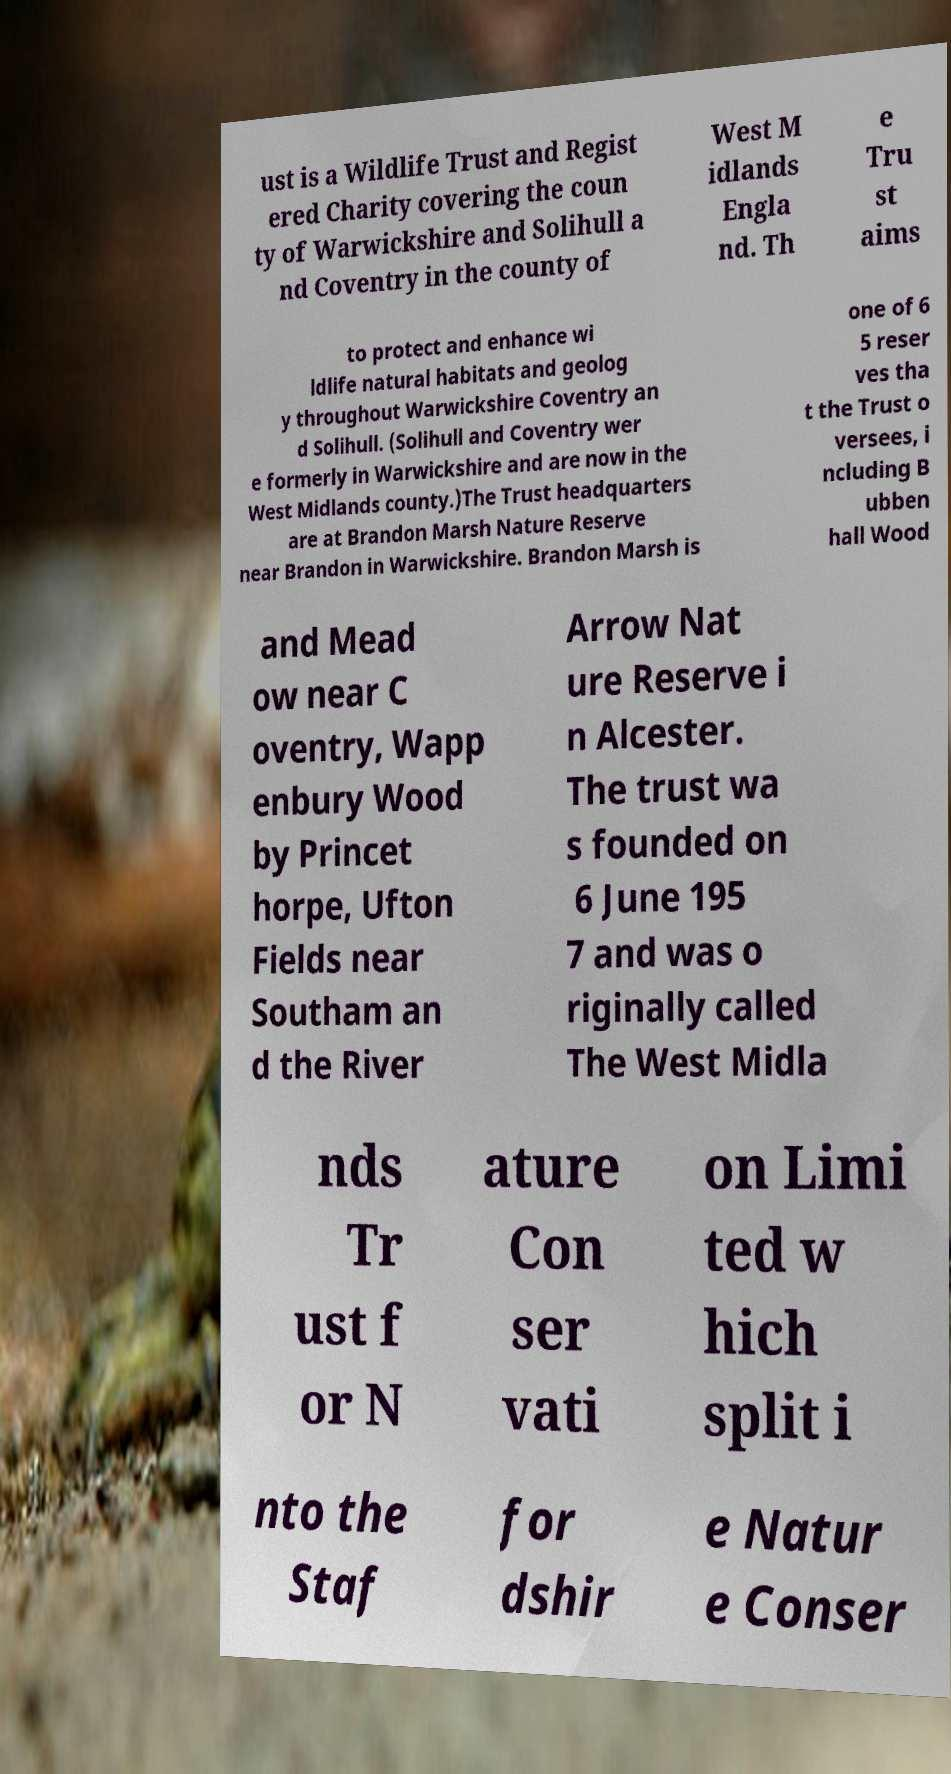Can you read and provide the text displayed in the image?This photo seems to have some interesting text. Can you extract and type it out for me? ust is a Wildlife Trust and Regist ered Charity covering the coun ty of Warwickshire and Solihull a nd Coventry in the county of West M idlands Engla nd. Th e Tru st aims to protect and enhance wi ldlife natural habitats and geolog y throughout Warwickshire Coventry an d Solihull. (Solihull and Coventry wer e formerly in Warwickshire and are now in the West Midlands county.)The Trust headquarters are at Brandon Marsh Nature Reserve near Brandon in Warwickshire. Brandon Marsh is one of 6 5 reser ves tha t the Trust o versees, i ncluding B ubben hall Wood and Mead ow near C oventry, Wapp enbury Wood by Princet horpe, Ufton Fields near Southam an d the River Arrow Nat ure Reserve i n Alcester. The trust wa s founded on 6 June 195 7 and was o riginally called The West Midla nds Tr ust f or N ature Con ser vati on Limi ted w hich split i nto the Staf for dshir e Natur e Conser 